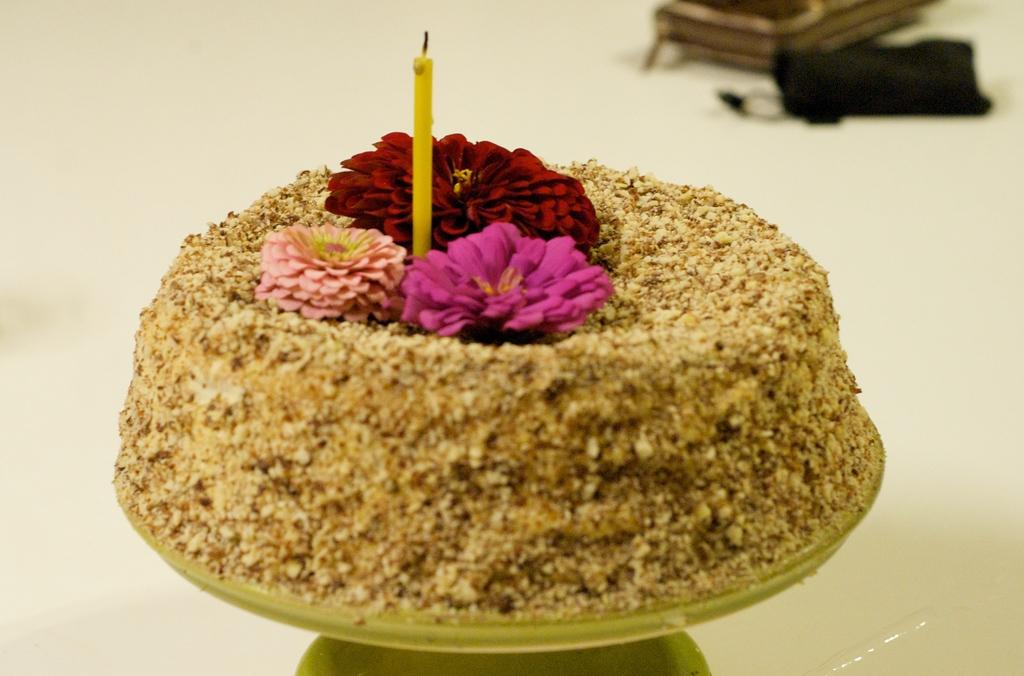What type of food item can be seen in the image? There is a food item in the image, but the specific type is not mentioned. What other elements are present in the image besides the food item? There are flowers and a candle in the image. On what surface are the objects placed? The objects are placed on an unspecified object. What can be seen below the objects? The ground is visible in the image. Are there any other objects on the ground? Yes, there are other objects on the ground. How many flies can be seen on the food item in the image? There are no flies present in the image, so it is not possible to determine their number. 